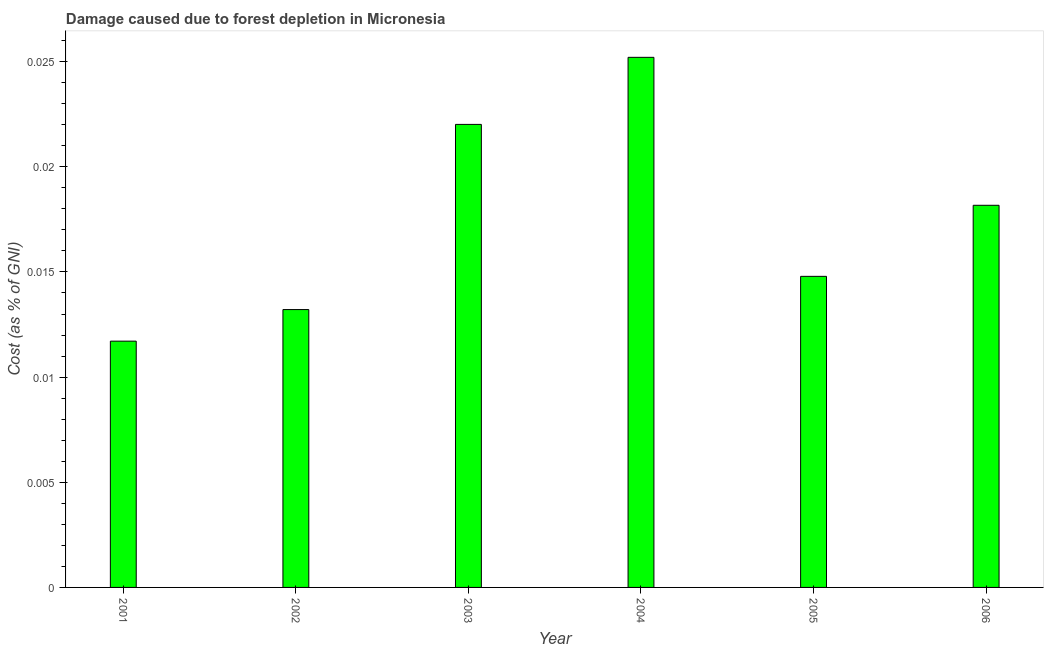Does the graph contain grids?
Your answer should be compact. No. What is the title of the graph?
Make the answer very short. Damage caused due to forest depletion in Micronesia. What is the label or title of the Y-axis?
Give a very brief answer. Cost (as % of GNI). What is the damage caused due to forest depletion in 2003?
Ensure brevity in your answer.  0.02. Across all years, what is the maximum damage caused due to forest depletion?
Offer a terse response. 0.03. Across all years, what is the minimum damage caused due to forest depletion?
Provide a succinct answer. 0.01. In which year was the damage caused due to forest depletion maximum?
Provide a succinct answer. 2004. In which year was the damage caused due to forest depletion minimum?
Keep it short and to the point. 2001. What is the sum of the damage caused due to forest depletion?
Make the answer very short. 0.11. What is the difference between the damage caused due to forest depletion in 2003 and 2005?
Your answer should be very brief. 0.01. What is the average damage caused due to forest depletion per year?
Your answer should be very brief. 0.02. What is the median damage caused due to forest depletion?
Keep it short and to the point. 0.02. In how many years, is the damage caused due to forest depletion greater than 0.012 %?
Ensure brevity in your answer.  5. What is the ratio of the damage caused due to forest depletion in 2003 to that in 2005?
Your answer should be very brief. 1.49. Is the damage caused due to forest depletion in 2003 less than that in 2005?
Offer a terse response. No. What is the difference between the highest and the second highest damage caused due to forest depletion?
Your answer should be compact. 0. Is the sum of the damage caused due to forest depletion in 2004 and 2006 greater than the maximum damage caused due to forest depletion across all years?
Provide a short and direct response. Yes. What is the difference between the highest and the lowest damage caused due to forest depletion?
Your answer should be very brief. 0.01. Are all the bars in the graph horizontal?
Give a very brief answer. No. How many years are there in the graph?
Give a very brief answer. 6. What is the difference between two consecutive major ticks on the Y-axis?
Your answer should be very brief. 0.01. Are the values on the major ticks of Y-axis written in scientific E-notation?
Make the answer very short. No. What is the Cost (as % of GNI) in 2001?
Your response must be concise. 0.01. What is the Cost (as % of GNI) of 2002?
Provide a short and direct response. 0.01. What is the Cost (as % of GNI) in 2003?
Keep it short and to the point. 0.02. What is the Cost (as % of GNI) of 2004?
Keep it short and to the point. 0.03. What is the Cost (as % of GNI) in 2005?
Your answer should be compact. 0.01. What is the Cost (as % of GNI) in 2006?
Provide a succinct answer. 0.02. What is the difference between the Cost (as % of GNI) in 2001 and 2002?
Ensure brevity in your answer.  -0. What is the difference between the Cost (as % of GNI) in 2001 and 2003?
Ensure brevity in your answer.  -0.01. What is the difference between the Cost (as % of GNI) in 2001 and 2004?
Offer a very short reply. -0.01. What is the difference between the Cost (as % of GNI) in 2001 and 2005?
Offer a terse response. -0. What is the difference between the Cost (as % of GNI) in 2001 and 2006?
Your answer should be very brief. -0.01. What is the difference between the Cost (as % of GNI) in 2002 and 2003?
Provide a short and direct response. -0.01. What is the difference between the Cost (as % of GNI) in 2002 and 2004?
Make the answer very short. -0.01. What is the difference between the Cost (as % of GNI) in 2002 and 2005?
Your response must be concise. -0. What is the difference between the Cost (as % of GNI) in 2002 and 2006?
Give a very brief answer. -0. What is the difference between the Cost (as % of GNI) in 2003 and 2004?
Provide a succinct answer. -0. What is the difference between the Cost (as % of GNI) in 2003 and 2005?
Your answer should be compact. 0.01. What is the difference between the Cost (as % of GNI) in 2003 and 2006?
Your answer should be compact. 0. What is the difference between the Cost (as % of GNI) in 2004 and 2005?
Your answer should be very brief. 0.01. What is the difference between the Cost (as % of GNI) in 2004 and 2006?
Make the answer very short. 0.01. What is the difference between the Cost (as % of GNI) in 2005 and 2006?
Provide a short and direct response. -0. What is the ratio of the Cost (as % of GNI) in 2001 to that in 2002?
Your answer should be very brief. 0.89. What is the ratio of the Cost (as % of GNI) in 2001 to that in 2003?
Provide a short and direct response. 0.53. What is the ratio of the Cost (as % of GNI) in 2001 to that in 2004?
Ensure brevity in your answer.  0.47. What is the ratio of the Cost (as % of GNI) in 2001 to that in 2005?
Keep it short and to the point. 0.79. What is the ratio of the Cost (as % of GNI) in 2001 to that in 2006?
Your answer should be compact. 0.64. What is the ratio of the Cost (as % of GNI) in 2002 to that in 2003?
Ensure brevity in your answer.  0.6. What is the ratio of the Cost (as % of GNI) in 2002 to that in 2004?
Provide a short and direct response. 0.52. What is the ratio of the Cost (as % of GNI) in 2002 to that in 2005?
Keep it short and to the point. 0.89. What is the ratio of the Cost (as % of GNI) in 2002 to that in 2006?
Give a very brief answer. 0.73. What is the ratio of the Cost (as % of GNI) in 2003 to that in 2004?
Provide a short and direct response. 0.87. What is the ratio of the Cost (as % of GNI) in 2003 to that in 2005?
Make the answer very short. 1.49. What is the ratio of the Cost (as % of GNI) in 2003 to that in 2006?
Make the answer very short. 1.21. What is the ratio of the Cost (as % of GNI) in 2004 to that in 2005?
Your answer should be compact. 1.7. What is the ratio of the Cost (as % of GNI) in 2004 to that in 2006?
Your answer should be compact. 1.39. What is the ratio of the Cost (as % of GNI) in 2005 to that in 2006?
Provide a short and direct response. 0.81. 